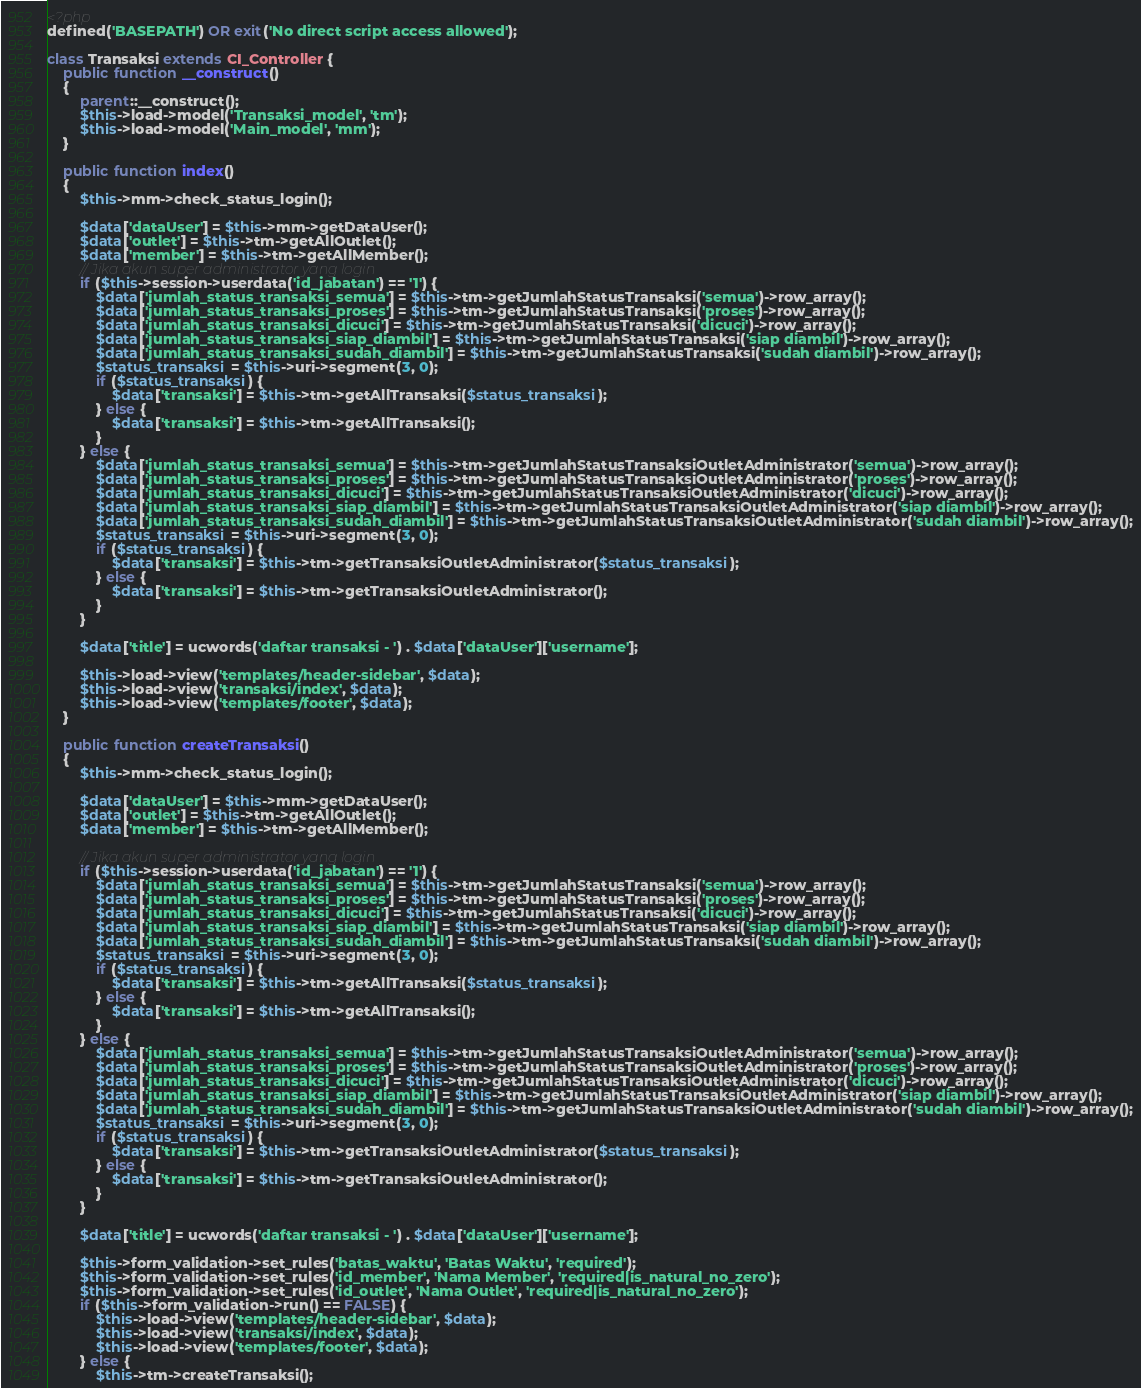Convert code to text. <code><loc_0><loc_0><loc_500><loc_500><_PHP_><?php
defined('BASEPATH') OR exit('No direct script access allowed');

class Transaksi extends CI_Controller {
	public function __construct()
	{
		parent::__construct();
		$this->load->model('Transaksi_model', 'tm');
		$this->load->model('Main_model', 'mm');
	}

	public function index()
	{
		$this->mm->check_status_login();
		
		$data['dataUser'] = $this->mm->getDataUser();
		$data['outlet'] = $this->tm->getAllOutlet();
		$data['member'] = $this->tm->getAllMember();
		// Jika akun super administrator yang login
		if ($this->session->userdata('id_jabatan') == '1') {
			$data['jumlah_status_transaksi_semua'] = $this->tm->getJumlahStatusTransaksi('semua')->row_array();
			$data['jumlah_status_transaksi_proses'] = $this->tm->getJumlahStatusTransaksi('proses')->row_array();
			$data['jumlah_status_transaksi_dicuci'] = $this->tm->getJumlahStatusTransaksi('dicuci')->row_array();
			$data['jumlah_status_transaksi_siap_diambil'] = $this->tm->getJumlahStatusTransaksi('siap diambil')->row_array();
			$data['jumlah_status_transaksi_sudah_diambil'] = $this->tm->getJumlahStatusTransaksi('sudah diambil')->row_array();
			$status_transaksi = $this->uri->segment(3, 0);
			if ($status_transaksi) {
				$data['transaksi'] = $this->tm->getAllTransaksi($status_transaksi);
			} else {
				$data['transaksi'] = $this->tm->getAllTransaksi();
			}
		} else {
			$data['jumlah_status_transaksi_semua'] = $this->tm->getJumlahStatusTransaksiOutletAdministrator('semua')->row_array();
			$data['jumlah_status_transaksi_proses'] = $this->tm->getJumlahStatusTransaksiOutletAdministrator('proses')->row_array();
			$data['jumlah_status_transaksi_dicuci'] = $this->tm->getJumlahStatusTransaksiOutletAdministrator('dicuci')->row_array();
			$data['jumlah_status_transaksi_siap_diambil'] = $this->tm->getJumlahStatusTransaksiOutletAdministrator('siap diambil')->row_array();
			$data['jumlah_status_transaksi_sudah_diambil'] = $this->tm->getJumlahStatusTransaksiOutletAdministrator('sudah diambil')->row_array();
			$status_transaksi = $this->uri->segment(3, 0);
			if ($status_transaksi) {
				$data['transaksi'] = $this->tm->getTransaksiOutletAdministrator($status_transaksi);
			} else {
				$data['transaksi'] = $this->tm->getTransaksiOutletAdministrator();
			}
		}

		$data['title'] = ucwords('daftar transaksi - ') . $data['dataUser']['username'];

		$this->load->view('templates/header-sidebar', $data);
		$this->load->view('transaksi/index', $data);
		$this->load->view('templates/footer', $data);
	}

	public function createTransaksi()
	{
		$this->mm->check_status_login();
		
		$data['dataUser'] = $this->mm->getDataUser();
		$data['outlet'] = $this->tm->getAllOutlet();
		$data['member'] = $this->tm->getAllMember();
		
		// Jika akun super administrator yang login
		if ($this->session->userdata('id_jabatan') == '1') {
			$data['jumlah_status_transaksi_semua'] = $this->tm->getJumlahStatusTransaksi('semua')->row_array();
			$data['jumlah_status_transaksi_proses'] = $this->tm->getJumlahStatusTransaksi('proses')->row_array();
			$data['jumlah_status_transaksi_dicuci'] = $this->tm->getJumlahStatusTransaksi('dicuci')->row_array();
			$data['jumlah_status_transaksi_siap_diambil'] = $this->tm->getJumlahStatusTransaksi('siap diambil')->row_array();
			$data['jumlah_status_transaksi_sudah_diambil'] = $this->tm->getJumlahStatusTransaksi('sudah diambil')->row_array();
			$status_transaksi = $this->uri->segment(3, 0);
			if ($status_transaksi) {
				$data['transaksi'] = $this->tm->getAllTransaksi($status_transaksi);
			} else {
				$data['transaksi'] = $this->tm->getAllTransaksi();
			}
		} else {
			$data['jumlah_status_transaksi_semua'] = $this->tm->getJumlahStatusTransaksiOutletAdministrator('semua')->row_array();
			$data['jumlah_status_transaksi_proses'] = $this->tm->getJumlahStatusTransaksiOutletAdministrator('proses')->row_array();
			$data['jumlah_status_transaksi_dicuci'] = $this->tm->getJumlahStatusTransaksiOutletAdministrator('dicuci')->row_array();
			$data['jumlah_status_transaksi_siap_diambil'] = $this->tm->getJumlahStatusTransaksiOutletAdministrator('siap diambil')->row_array();
			$data['jumlah_status_transaksi_sudah_diambil'] = $this->tm->getJumlahStatusTransaksiOutletAdministrator('sudah diambil')->row_array();
			$status_transaksi = $this->uri->segment(3, 0);
			if ($status_transaksi) {
				$data['transaksi'] = $this->tm->getTransaksiOutletAdministrator($status_transaksi);
			} else {
				$data['transaksi'] = $this->tm->getTransaksiOutletAdministrator();
			}
		}

		$data['title'] = ucwords('daftar transaksi - ') . $data['dataUser']['username'];
		
		$this->form_validation->set_rules('batas_waktu', 'Batas Waktu', 'required');
		$this->form_validation->set_rules('id_member', 'Nama Member', 'required|is_natural_no_zero');
		$this->form_validation->set_rules('id_outlet', 'Nama Outlet', 'required|is_natural_no_zero');
		if ($this->form_validation->run() == FALSE) {
			$this->load->view('templates/header-sidebar', $data);
			$this->load->view('transaksi/index', $data);
			$this->load->view('templates/footer', $data);
		} else {
			$this->tm->createTransaksi();</code> 